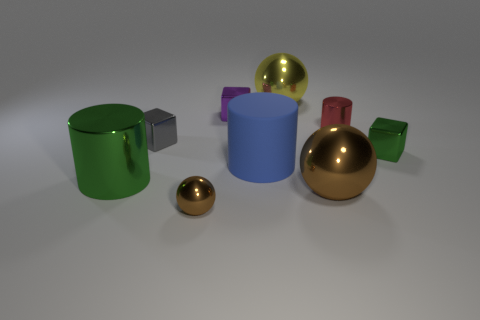Subtract 1 spheres. How many spheres are left? 2 Add 1 brown objects. How many objects exist? 10 Subtract all cylinders. How many objects are left? 6 Add 8 yellow metal things. How many yellow metal things exist? 9 Subtract 0 red cubes. How many objects are left? 9 Subtract all large brown rubber cylinders. Subtract all large green cylinders. How many objects are left? 8 Add 1 small green things. How many small green things are left? 2 